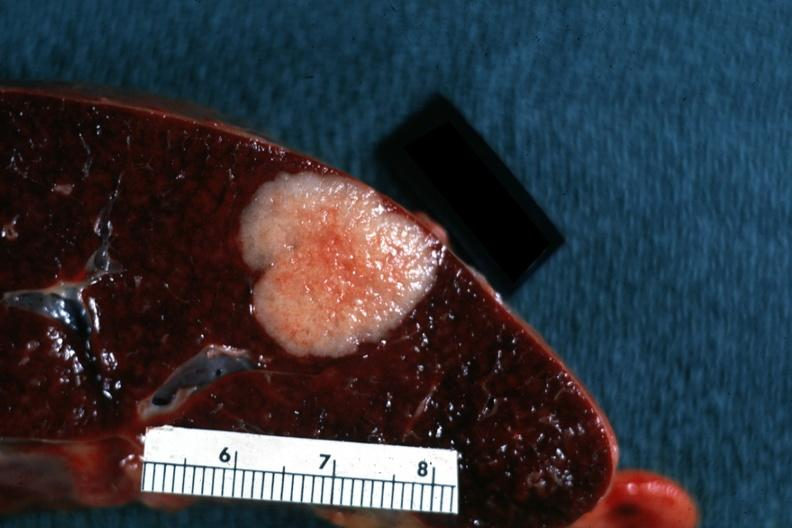s infarcts present?
Answer the question using a single word or phrase. No 